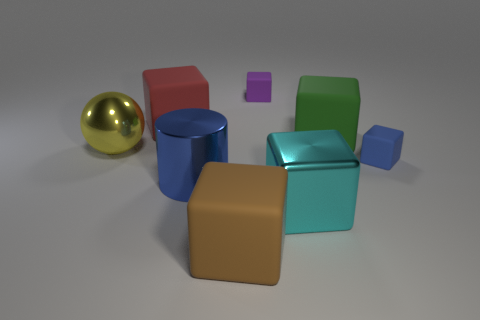Subtract all brown rubber cubes. How many cubes are left? 5 Subtract all cyan cubes. How many cubes are left? 5 Subtract all blue blocks. Subtract all yellow spheres. How many blocks are left? 5 Add 2 green matte spheres. How many objects exist? 10 Subtract all cubes. How many objects are left? 2 Subtract all small gray metallic cubes. Subtract all tiny blocks. How many objects are left? 6 Add 3 tiny blocks. How many tiny blocks are left? 5 Add 7 big cyan metallic objects. How many big cyan metallic objects exist? 8 Subtract 0 purple cylinders. How many objects are left? 8 